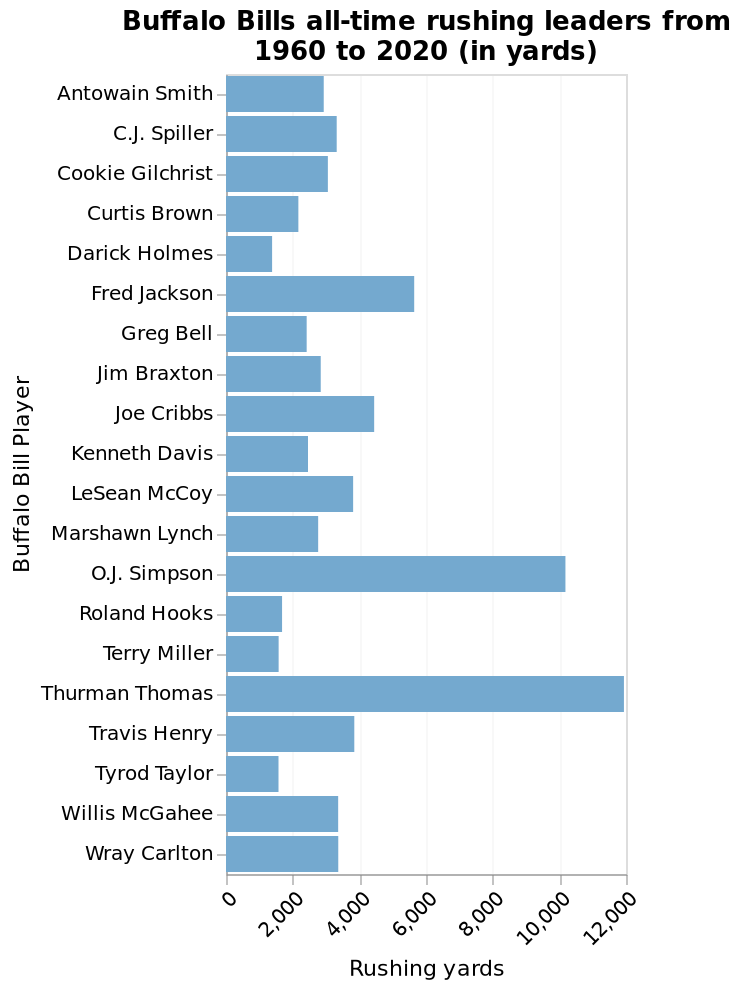<image>
Is it possible for a Buffalo Bills player to have rushing yards exactly equal to 4000? Yes, it is possible for a Buffalo Bills player to have rushing yards exactly equal to 4000, as the majority of them fall within that range. Are there any Buffalo Bills players who have rushing yards less than 2000?  No, according to the given information, the majority of Buffalo Bills have rushing yards between 2000 and 4000. please describe the details of the chart Buffalo Bills all-time rushing leaders from 1960 to 2020 (in yards) is a bar chart. The x-axis plots Rushing yards as linear scale from 0 to 12,000 while the y-axis shows Buffalo Bill Player along categorical scale from Antowain Smith to Wray Carlton. please summary the statistics and relations of the chart The majority of Buffalo Bills have rushing yards between 2000 and 4000. Do the majority of Buffalo Bills have rushing yards between 7000 and 10000? No.The majority of Buffalo Bills have rushing yards between 2000 and 4000. 